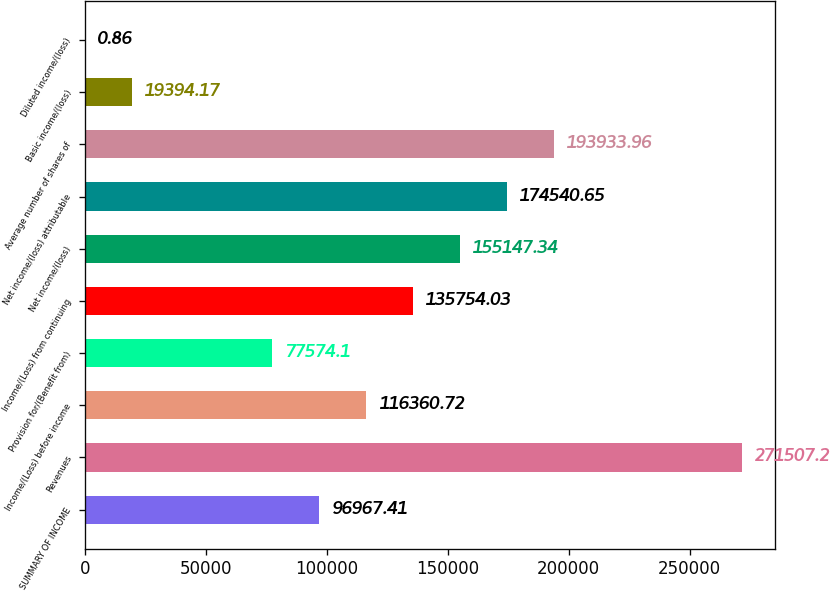Convert chart to OTSL. <chart><loc_0><loc_0><loc_500><loc_500><bar_chart><fcel>SUMMARY OF INCOME<fcel>Revenues<fcel>Income/(Loss) before income<fcel>Provision for/(Benefit from)<fcel>Income/(Loss) from continuing<fcel>Net income/(loss)<fcel>Net income/(loss) attributable<fcel>Average number of shares of<fcel>Basic income/(loss)<fcel>Diluted income/(loss)<nl><fcel>96967.4<fcel>271507<fcel>116361<fcel>77574.1<fcel>135754<fcel>155147<fcel>174541<fcel>193934<fcel>19394.2<fcel>0.86<nl></chart> 